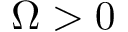<formula> <loc_0><loc_0><loc_500><loc_500>\Omega > 0</formula> 